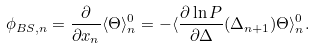Convert formula to latex. <formula><loc_0><loc_0><loc_500><loc_500>\phi _ { B S , n } = \frac { \partial } { \partial x _ { n } } \langle \Theta \rangle _ { n } ^ { 0 } = - \langle \frac { \partial \ln P } { \partial \Delta } ( \Delta _ { n + 1 } ) \Theta \rangle _ { n } ^ { 0 } .</formula> 